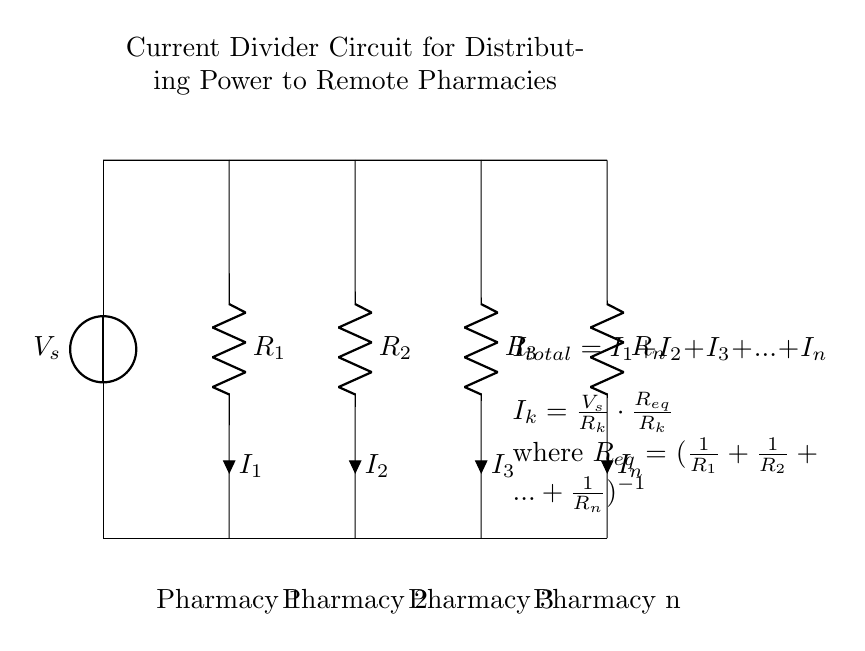What is the source voltage of the circuit? The source voltage is denoted by V_s in the circuit diagram. It represents the total voltage supplied to the circuit.
Answer: V_s What is the total current flowing through the circuit? The total current is the sum of all individual currents flowing through each resistor, as indicated by the equation I_total = I_1 + I_2 + I_3 + ... + I_n.
Answer: I_total How many pharmacies are connected in this circuit? The diagram clearly shows four resistors (R_1, R_2, R_3, and R_n) representing four pharmacies (Pharmacy 1, Pharmacy 2, Pharmacy 3, and Pharmacy n).
Answer: Four What is the relationship between voltage and resistance in this circuit? The circuit shows that each individual current (I_k) is proportional to the source voltage (V_s) divided by the resistance (R_k). This indicates that as resistance increases, the current decreases.
Answer: Inverse relationship How is the current distributed among the pharmacies? The current through each pharmacy is determined by the formula I_k = V_s / R_k * R_eq / R_k, which shows that current is inversely proportional to the resistance of each branch. This means lower resistance leads to higher current for that branch.
Answer: Inversely proportional What is the equivalent resistance of the circuit? The equivalent resistance (R_eq) is calculated using the formula R_eq = (1/(1/R_1 + 1/R_2 + ... + 1/R_n)) to combine the resistances in parallel. This is key for determining how current divides among the pharmacies.
Answer: R_eq 